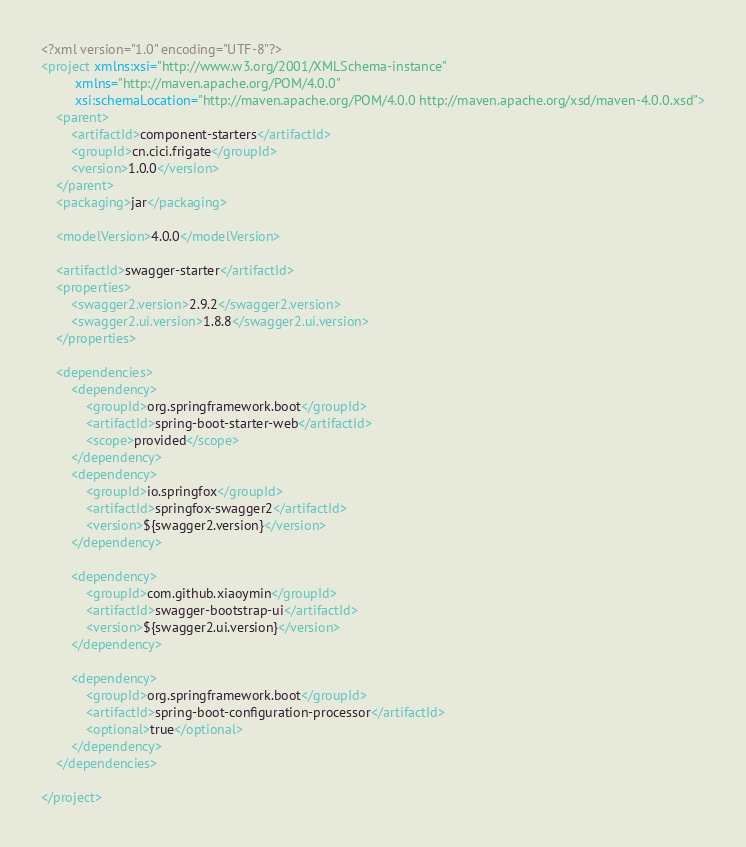Convert code to text. <code><loc_0><loc_0><loc_500><loc_500><_XML_><?xml version="1.0" encoding="UTF-8"?>
<project xmlns:xsi="http://www.w3.org/2001/XMLSchema-instance"
         xmlns="http://maven.apache.org/POM/4.0.0"
         xsi:schemaLocation="http://maven.apache.org/POM/4.0.0 http://maven.apache.org/xsd/maven-4.0.0.xsd">
    <parent>
        <artifactId>component-starters</artifactId>
        <groupId>cn.cici.frigate</groupId>
        <version>1.0.0</version>
    </parent>
    <packaging>jar</packaging>

    <modelVersion>4.0.0</modelVersion>

    <artifactId>swagger-starter</artifactId>
    <properties>
        <swagger2.version>2.9.2</swagger2.version>
        <swagger2.ui.version>1.8.8</swagger2.ui.version>
    </properties>

    <dependencies>
        <dependency>
            <groupId>org.springframework.boot</groupId>
            <artifactId>spring-boot-starter-web</artifactId>
            <scope>provided</scope>
        </dependency>
        <dependency>
            <groupId>io.springfox</groupId>
            <artifactId>springfox-swagger2</artifactId>
            <version>${swagger2.version}</version>
        </dependency>

        <dependency>
            <groupId>com.github.xiaoymin</groupId>
            <artifactId>swagger-bootstrap-ui</artifactId>
            <version>${swagger2.ui.version}</version>
        </dependency>

        <dependency>
            <groupId>org.springframework.boot</groupId>
            <artifactId>spring-boot-configuration-processor</artifactId>
            <optional>true</optional>
        </dependency>
    </dependencies>

</project></code> 